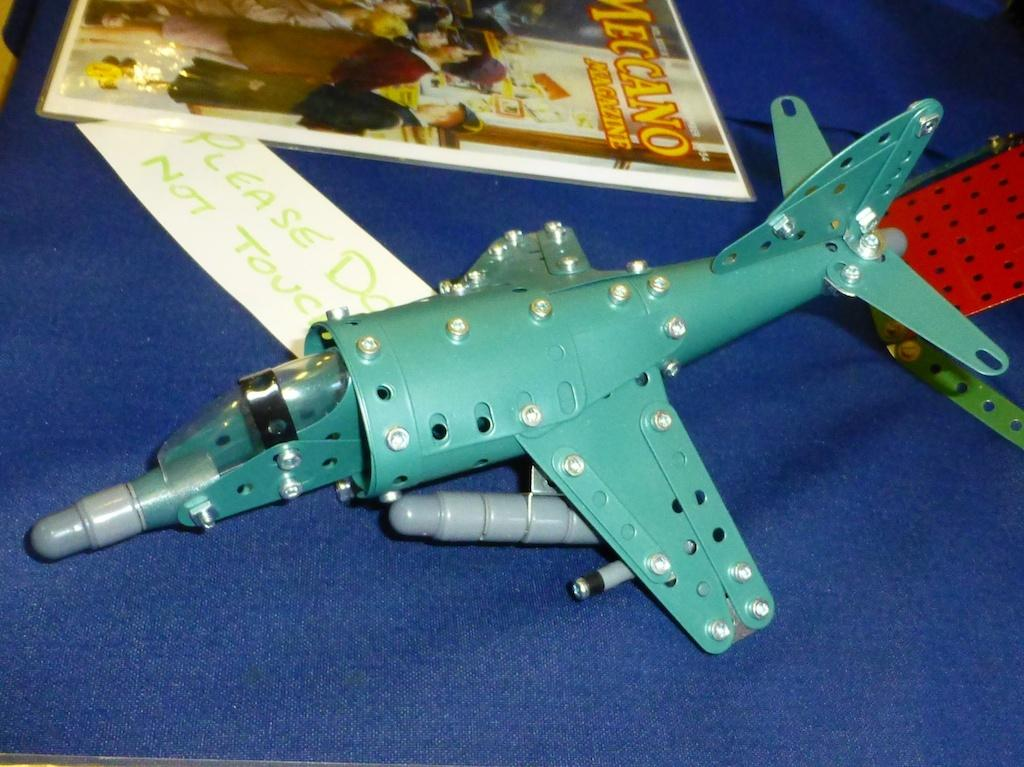Provide a one-sentence caption for the provided image. A toy Construx plane sits next to a handwritten note imploring Please Do Not Touch. 